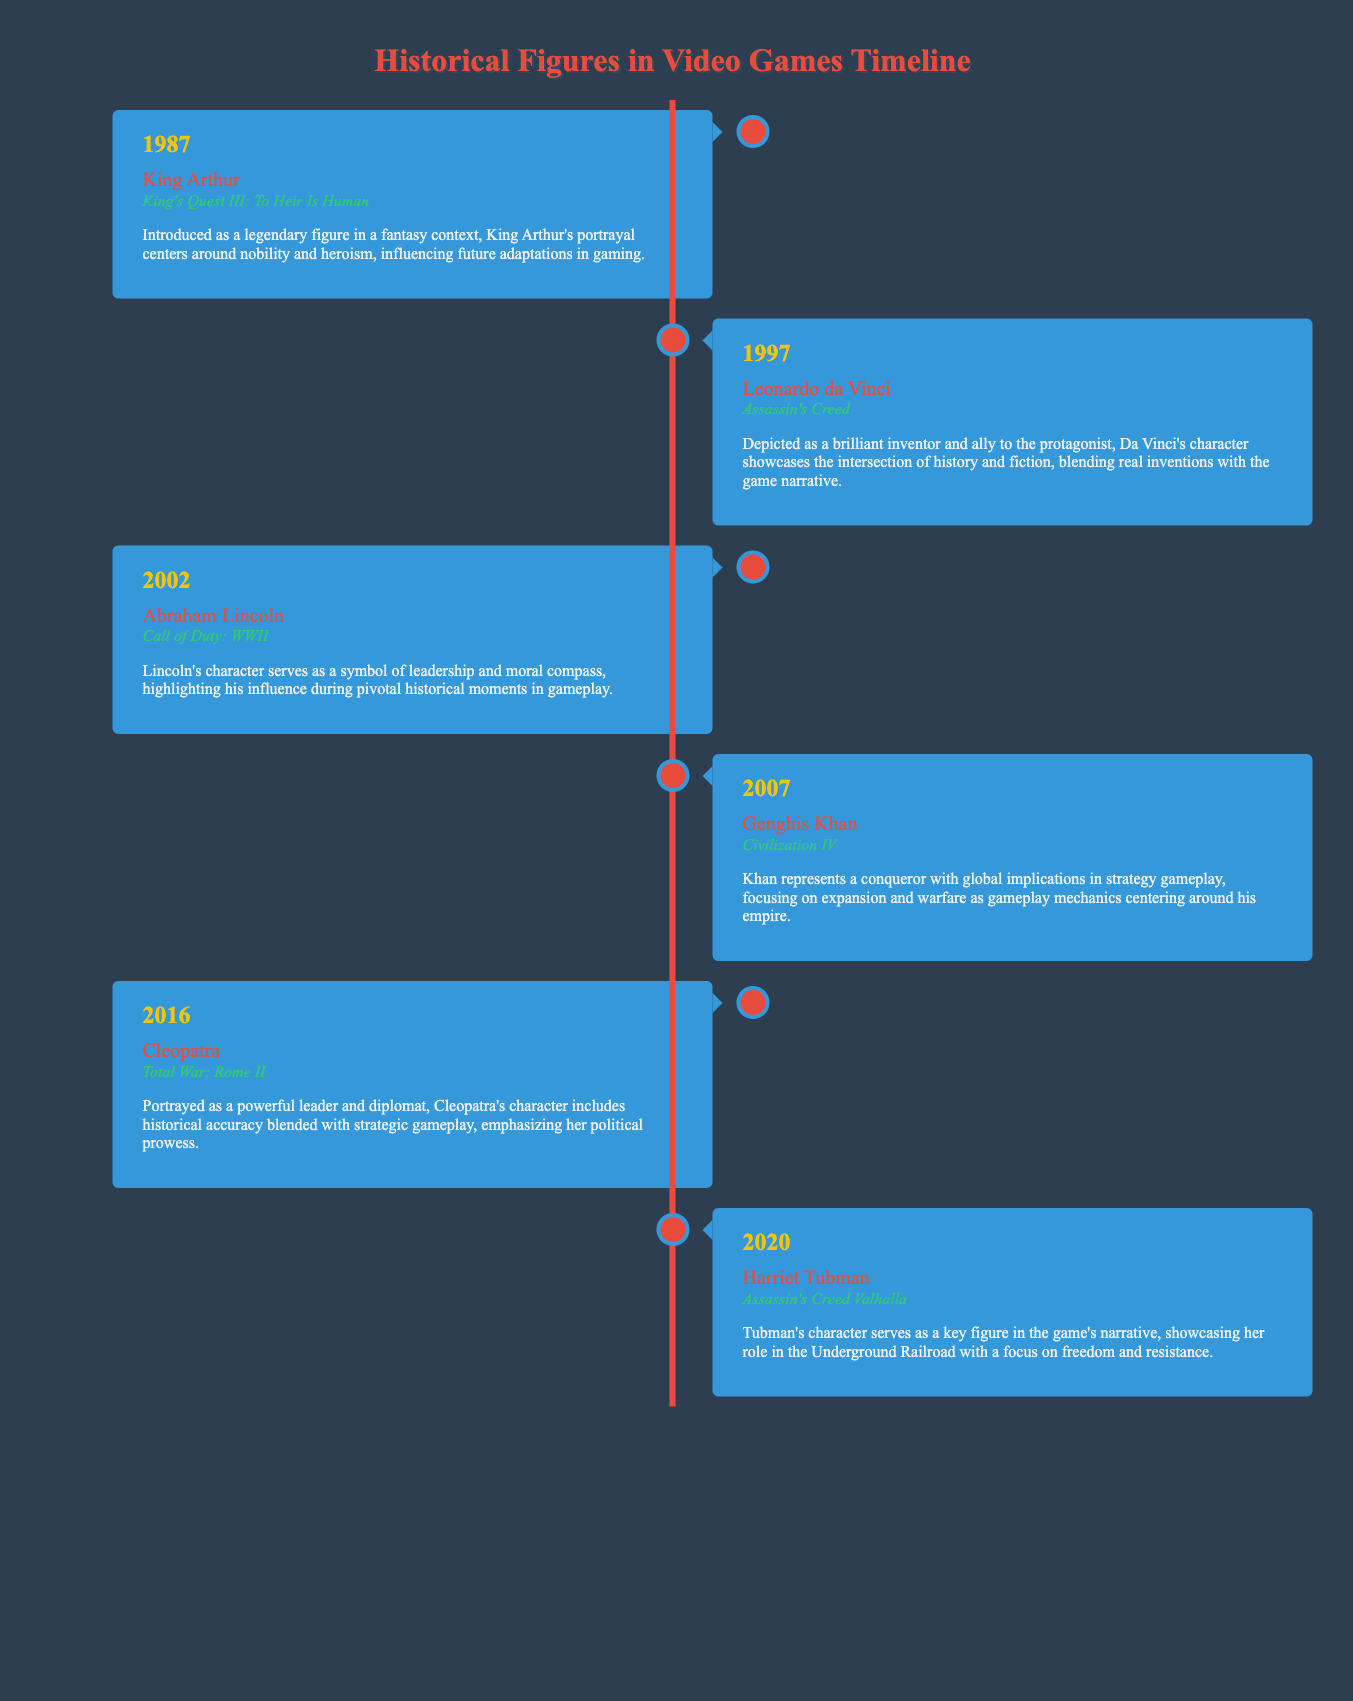what year was King Arthur introduced? King Arthur was introduced in the year stated in the document.
Answer: 1987 which game featured Leonardo da Vinci? The game that features Leonardo da Vinci is mentioned in the document.
Answer: Assassin's Creed who is depicted as a symbol of leadership in the timeline? The document shows that Abraham Lincoln represents leadership.
Answer: Abraham Lincoln what historical figure is included in Civilization IV? The historical figure mentioned in the document for Civilization IV.
Answer: Genghis Khan which game showcases Harriet Tubman? The specific game that features Harriet Tubman is noted in the timeline.
Answer: Assassin's Creed Valhalla in what year was Cleopatra portrayed as a diplomat? The document indicates the year when Cleopatra's portrayal occurred.
Answer: 2016 how many historical figures are discussed in the timeline? The total number of figures included can be counted from the entries in the document.
Answer: Six what theme is emphasized through Cleopatra's character in the game? The document elaborates on Cleopatra's strengths within the game context.
Answer: Political prowess who represents the Underground Railroad in the timeline? The figure associated with the Underground Railroad is stated in the document.
Answer: Harriet Tubman 